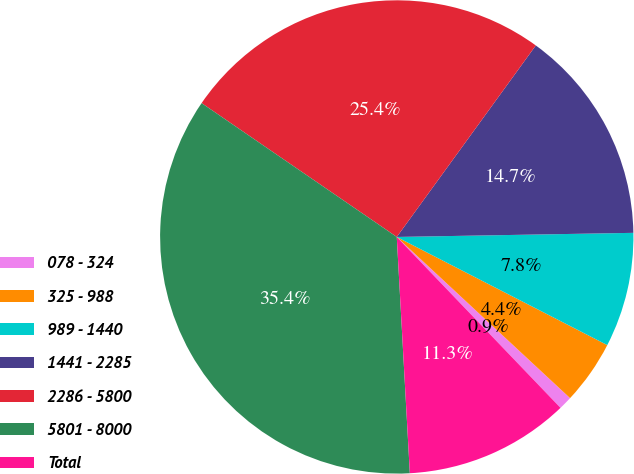Convert chart to OTSL. <chart><loc_0><loc_0><loc_500><loc_500><pie_chart><fcel>078 - 324<fcel>325 - 988<fcel>989 - 1440<fcel>1441 - 2285<fcel>2286 - 5800<fcel>5801 - 8000<fcel>Total<nl><fcel>0.92%<fcel>4.37%<fcel>7.83%<fcel>14.73%<fcel>25.43%<fcel>35.45%<fcel>11.28%<nl></chart> 